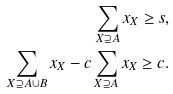Convert formula to latex. <formula><loc_0><loc_0><loc_500><loc_500>\sum _ { X \supseteq A } x _ { X } \geq s , \\ \sum _ { X \supseteq A \cup B } x _ { X } - c \sum _ { X \supseteq A } x _ { X } \geq c .</formula> 